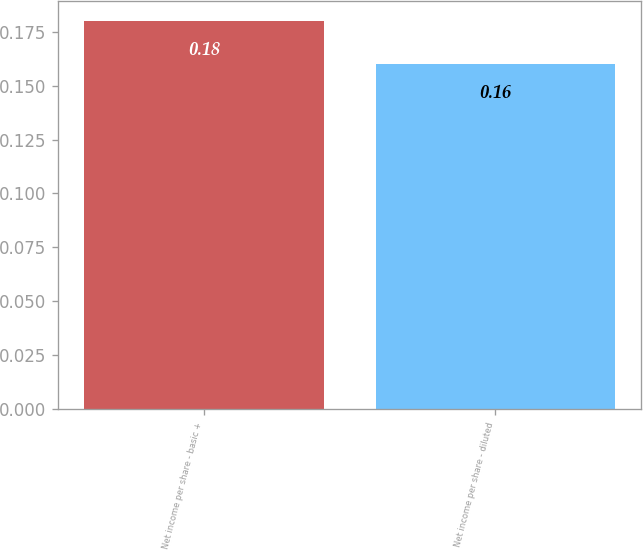<chart> <loc_0><loc_0><loc_500><loc_500><bar_chart><fcel>Net income per share - basic +<fcel>Net income per share - diluted<nl><fcel>0.18<fcel>0.16<nl></chart> 